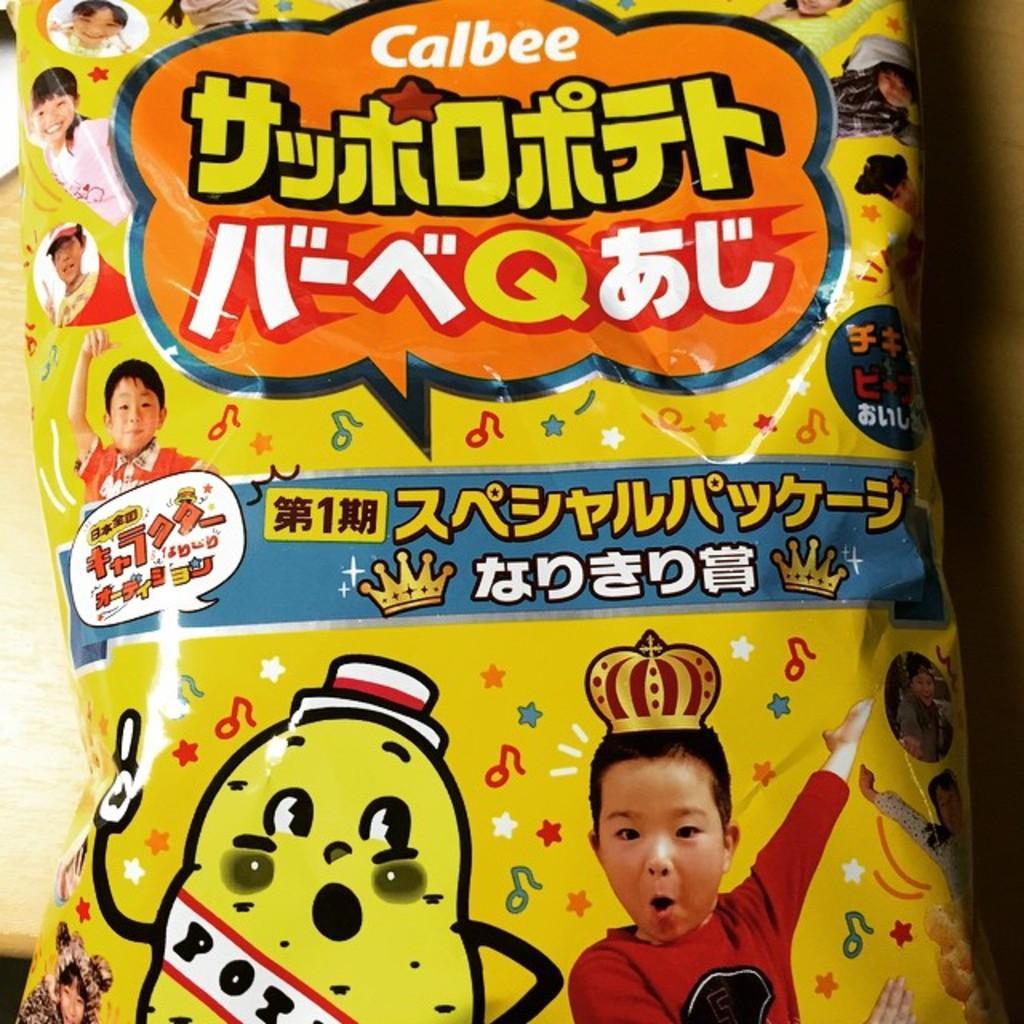Could you give a brief overview of what you see in this image? In this image we can see a packet on a platform. On the packet we can see pictures of few persons, cartoon images and texts written on it. 